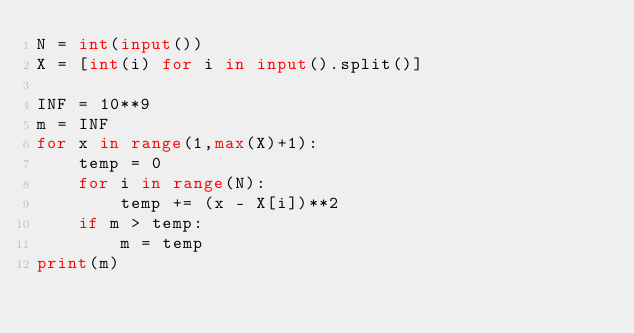<code> <loc_0><loc_0><loc_500><loc_500><_Python_>N = int(input())
X = [int(i) for i in input().split()]

INF = 10**9
m = INF
for x in range(1,max(X)+1):
    temp = 0
    for i in range(N):
        temp += (x - X[i])**2
    if m > temp:
        m = temp
print(m)</code> 